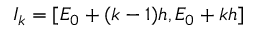Convert formula to latex. <formula><loc_0><loc_0><loc_500><loc_500>I _ { k } = [ E _ { 0 } + ( k - 1 ) h , E _ { 0 } + k h ]</formula> 